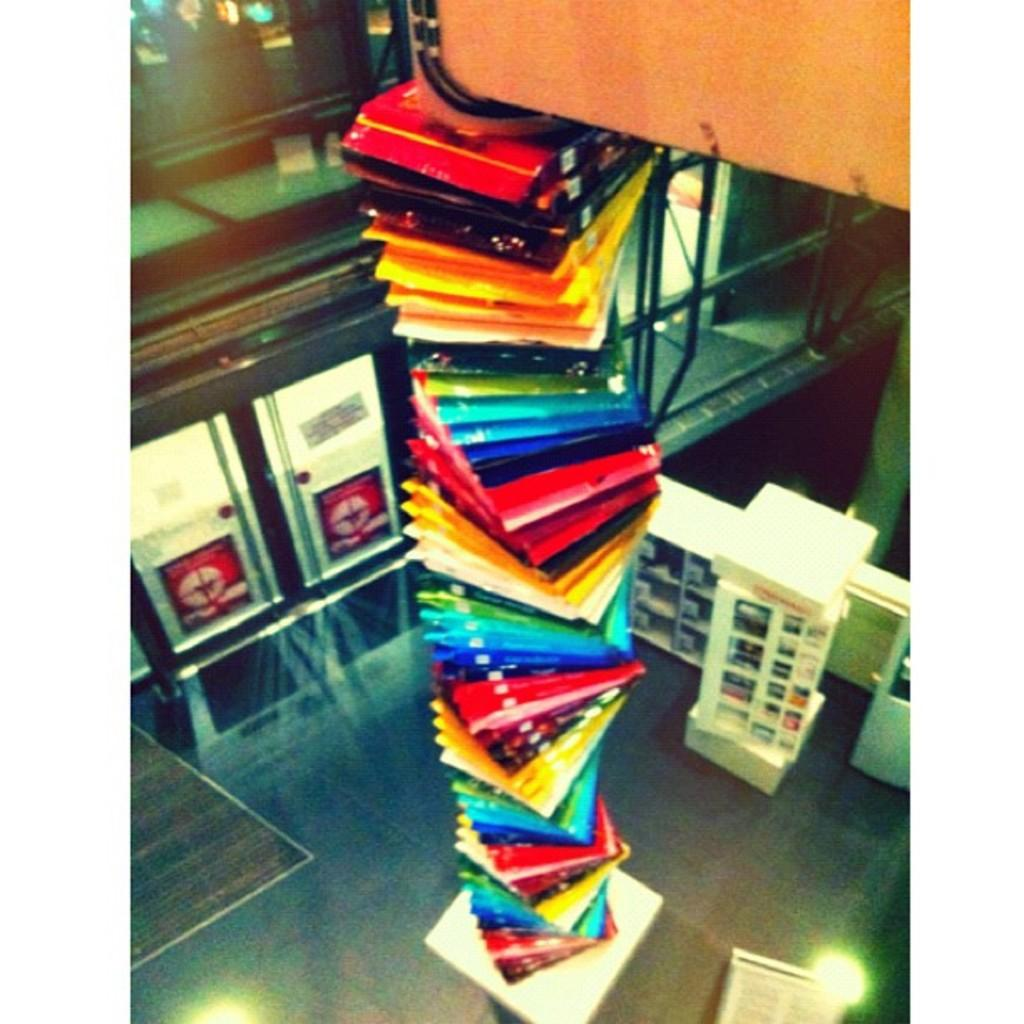What type of objects can be seen in the image? There are colorful boxes in the image. Where is the door located in the image? The door is on the left side of the image. What can be found on the right side of the image? There are pipes on the right side of the image. What type of corn is being grown in the image? There is no corn present in the image; it features colorful boxes, a door, and pipes. How does the rat interact with the boxes in the image? There is no rat present in the image, so it cannot interact with the boxes. 